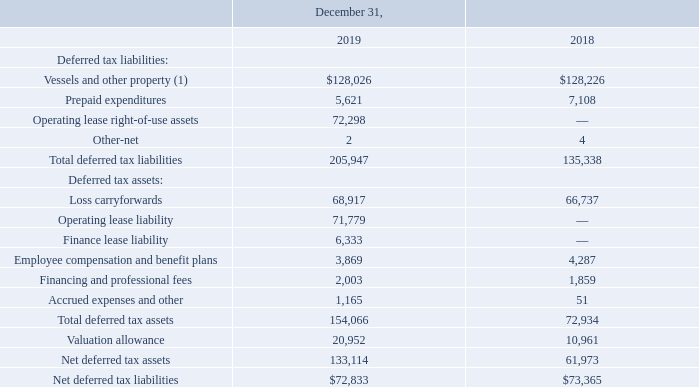The significant components of the Company’s deferred tax liabilities and assets follow:
(1) Includes deferred tax liabilities related to finance lease right-of-use assets totaling $6,190 and $0 at December 31, 2019 and 2018, respectively.
As of December 31, 2019, the Company had U.S. federal net operating loss carryforwards of $213,800 which are available to reduce future taxes, if any. The federal net operating loss carryforwards begin to expire in 2034. Additionally, as of December 31, 2019, the Company had U.S. state net operating loss carryforwards of $445,936.
This includes net operating losses previously unrecorded due to minimal projected income in those jurisdictions. These U.S. state net operating loss carryforwards expire in various years ending from December 31, 2019 through December 31, 2035. Included in the financing and professional fees deferred income assets above are U.S. federal interest expense deductions with an indefinite carryforward period.
There was a change of control in the Company during 2014 that limited the annual usage of pre-ownership change net operating losses. All pre-ownership change net operating losses were fully utilized in 2019.
The Company assessed all available positive and negative evidence to determine whether sufficient future taxable income will be generated to permit use of existing deferred tax assets. For U.S. federal deferred tax assets, the Company concluded that sufficient positive evidence existed, primarily the result of reversing deferred tax liabilities during the carryover period.
However, for certain state deferred tax assets, the negative evidence has outweighed the positive evidence which has resulted in the Company establishing a valuation allowance of $20,952 and $10,961 as of December 31, 2019 and 2018, respectively, to recognize only the portion of the deferred tax asset that is more likely than not to be realized.
During the years ended December 31, 2019 and 2018, the Company paid (net of refunds received) $1,293 and $1,313, respectively, of income taxes.
How much did the company paid (net of refunds received) of income taxes during the years ended December 31, 2019 and 2018 respectively? $1,293, $1,313. What is the change in Net deferred tax liabilities from December 31, 2018 to 2019? 72,833-73,365
Answer: -532. What is the average Net deferred tax liabilities for December 31, 2018 to 2019? (72,833+73,365) / 2
Answer: 73099. In which year was Prepaid expenditures less than 6,000? Locate and analyze prepaid expenditures in row 5
answer: 2019. What was the Prepaid expenditures in 2019 and 2018 respectively? 5,621, 7,108. What was the total deferred tax liabilities in 2019? 205,947. 